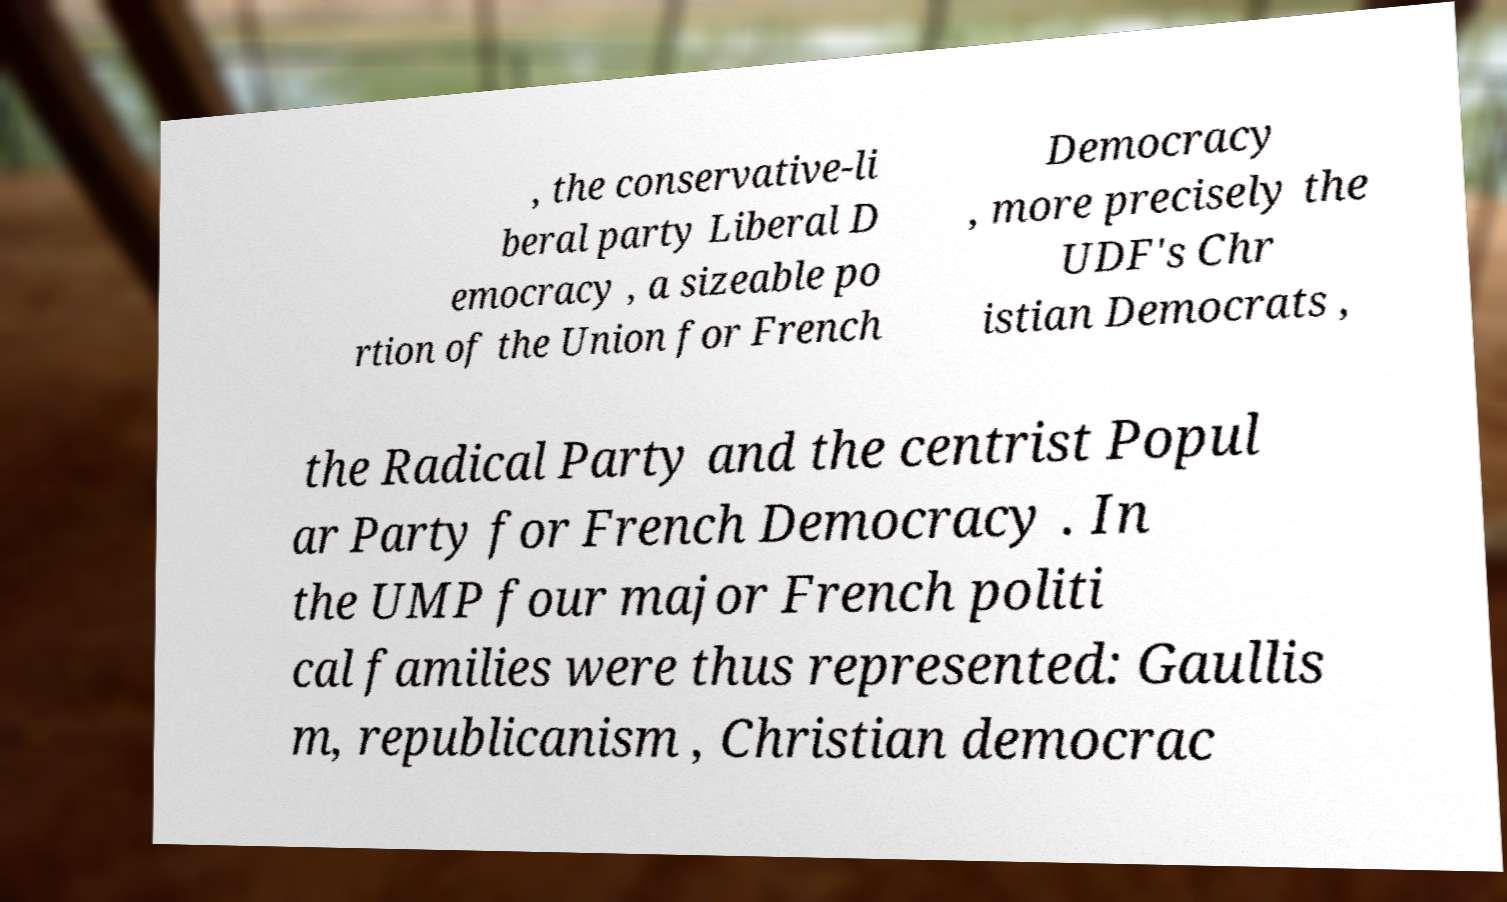I need the written content from this picture converted into text. Can you do that? , the conservative-li beral party Liberal D emocracy , a sizeable po rtion of the Union for French Democracy , more precisely the UDF's Chr istian Democrats , the Radical Party and the centrist Popul ar Party for French Democracy . In the UMP four major French politi cal families were thus represented: Gaullis m, republicanism , Christian democrac 